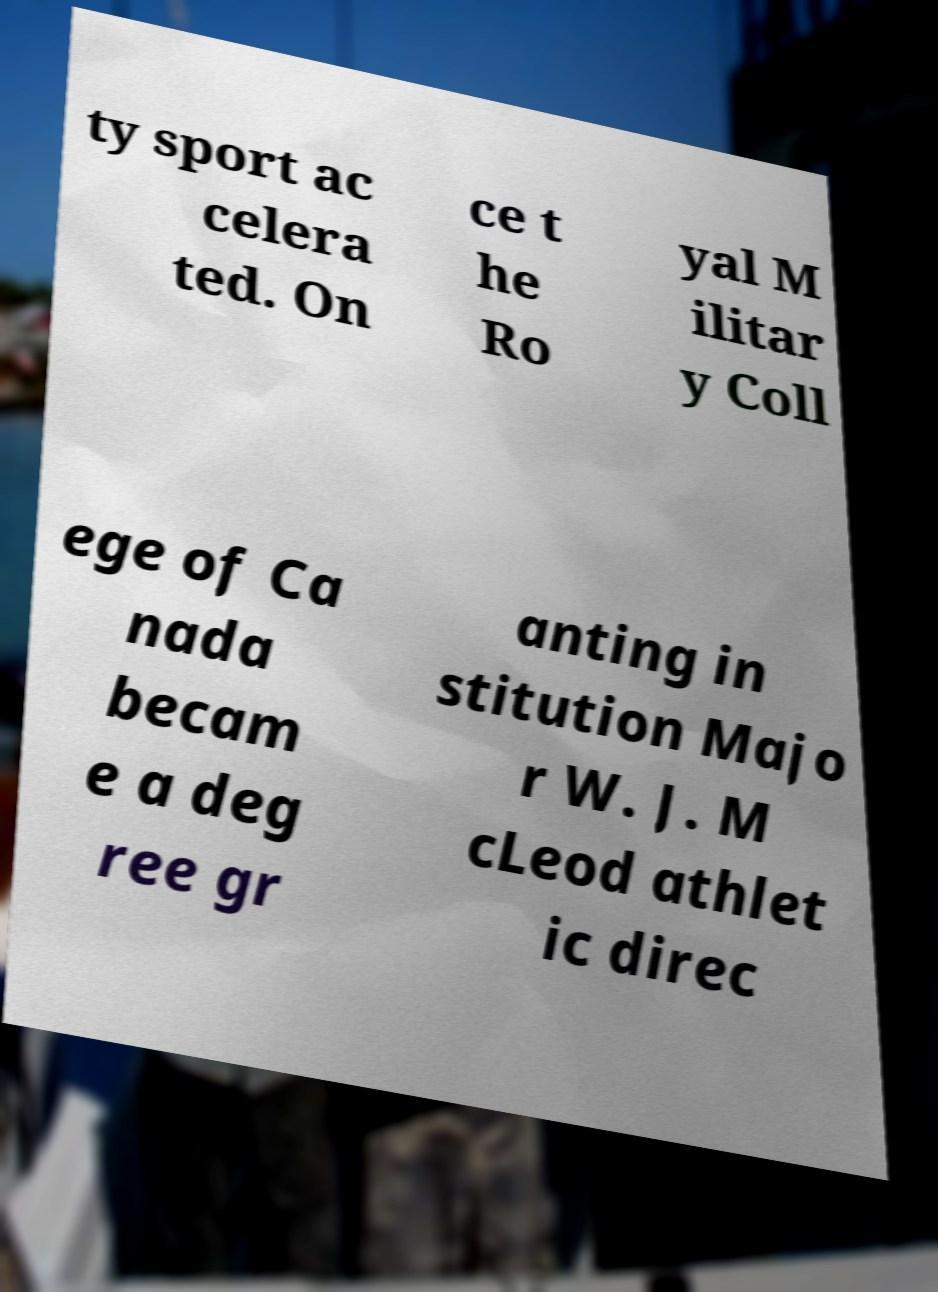For documentation purposes, I need the text within this image transcribed. Could you provide that? ty sport ac celera ted. On ce t he Ro yal M ilitar y Coll ege of Ca nada becam e a deg ree gr anting in stitution Majo r W. J. M cLeod athlet ic direc 